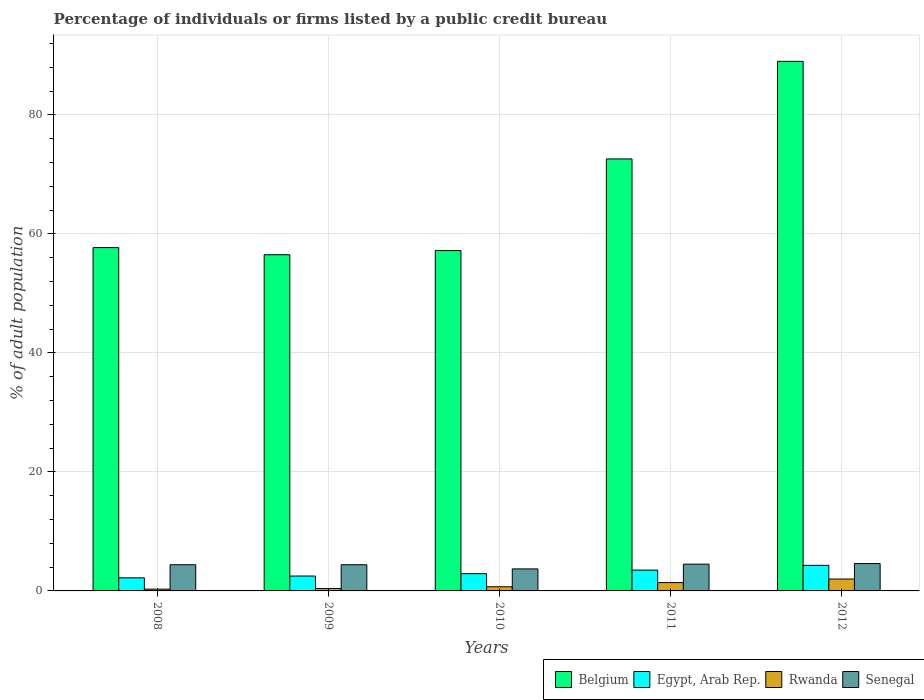How many different coloured bars are there?
Your answer should be very brief. 4. How many bars are there on the 2nd tick from the right?
Your answer should be very brief. 4. What is the label of the 4th group of bars from the left?
Your response must be concise. 2011. What is the percentage of population listed by a public credit bureau in Belgium in 2010?
Your answer should be compact. 57.2. Across all years, what is the maximum percentage of population listed by a public credit bureau in Belgium?
Provide a short and direct response. 89. Across all years, what is the minimum percentage of population listed by a public credit bureau in Rwanda?
Your answer should be compact. 0.3. What is the total percentage of population listed by a public credit bureau in Senegal in the graph?
Your answer should be very brief. 21.6. What is the average percentage of population listed by a public credit bureau in Belgium per year?
Offer a very short reply. 66.6. In the year 2012, what is the difference between the percentage of population listed by a public credit bureau in Senegal and percentage of population listed by a public credit bureau in Rwanda?
Your response must be concise. 2.6. What is the ratio of the percentage of population listed by a public credit bureau in Rwanda in 2011 to that in 2012?
Your answer should be compact. 0.7. Is the difference between the percentage of population listed by a public credit bureau in Senegal in 2008 and 2011 greater than the difference between the percentage of population listed by a public credit bureau in Rwanda in 2008 and 2011?
Ensure brevity in your answer.  Yes. What is the difference between the highest and the second highest percentage of population listed by a public credit bureau in Rwanda?
Keep it short and to the point. 0.6. What is the difference between the highest and the lowest percentage of population listed by a public credit bureau in Rwanda?
Provide a short and direct response. 1.7. Is the sum of the percentage of population listed by a public credit bureau in Rwanda in 2008 and 2009 greater than the maximum percentage of population listed by a public credit bureau in Senegal across all years?
Give a very brief answer. No. Is it the case that in every year, the sum of the percentage of population listed by a public credit bureau in Rwanda and percentage of population listed by a public credit bureau in Senegal is greater than the sum of percentage of population listed by a public credit bureau in Belgium and percentage of population listed by a public credit bureau in Egypt, Arab Rep.?
Offer a terse response. Yes. Is it the case that in every year, the sum of the percentage of population listed by a public credit bureau in Rwanda and percentage of population listed by a public credit bureau in Senegal is greater than the percentage of population listed by a public credit bureau in Egypt, Arab Rep.?
Keep it short and to the point. Yes. How many bars are there?
Ensure brevity in your answer.  20. How many years are there in the graph?
Provide a short and direct response. 5. Are the values on the major ticks of Y-axis written in scientific E-notation?
Your answer should be compact. No. Where does the legend appear in the graph?
Make the answer very short. Bottom right. What is the title of the graph?
Offer a terse response. Percentage of individuals or firms listed by a public credit bureau. Does "Comoros" appear as one of the legend labels in the graph?
Your answer should be very brief. No. What is the label or title of the Y-axis?
Ensure brevity in your answer.  % of adult population. What is the % of adult population in Belgium in 2008?
Ensure brevity in your answer.  57.7. What is the % of adult population in Egypt, Arab Rep. in 2008?
Your answer should be compact. 2.2. What is the % of adult population of Rwanda in 2008?
Make the answer very short. 0.3. What is the % of adult population of Belgium in 2009?
Keep it short and to the point. 56.5. What is the % of adult population in Egypt, Arab Rep. in 2009?
Provide a short and direct response. 2.5. What is the % of adult population in Rwanda in 2009?
Offer a very short reply. 0.4. What is the % of adult population in Senegal in 2009?
Offer a very short reply. 4.4. What is the % of adult population of Belgium in 2010?
Make the answer very short. 57.2. What is the % of adult population in Egypt, Arab Rep. in 2010?
Your answer should be very brief. 2.9. What is the % of adult population of Rwanda in 2010?
Your answer should be very brief. 0.7. What is the % of adult population of Belgium in 2011?
Provide a succinct answer. 72.6. What is the % of adult population of Senegal in 2011?
Give a very brief answer. 4.5. What is the % of adult population in Belgium in 2012?
Make the answer very short. 89. What is the % of adult population in Rwanda in 2012?
Keep it short and to the point. 2. What is the % of adult population of Senegal in 2012?
Keep it short and to the point. 4.6. Across all years, what is the maximum % of adult population of Belgium?
Provide a short and direct response. 89. Across all years, what is the maximum % of adult population of Rwanda?
Provide a short and direct response. 2. Across all years, what is the minimum % of adult population of Belgium?
Provide a succinct answer. 56.5. Across all years, what is the minimum % of adult population of Senegal?
Offer a very short reply. 3.7. What is the total % of adult population of Belgium in the graph?
Keep it short and to the point. 333. What is the total % of adult population in Senegal in the graph?
Your answer should be very brief. 21.6. What is the difference between the % of adult population in Belgium in 2008 and that in 2009?
Keep it short and to the point. 1.2. What is the difference between the % of adult population of Egypt, Arab Rep. in 2008 and that in 2009?
Offer a terse response. -0.3. What is the difference between the % of adult population in Senegal in 2008 and that in 2009?
Your answer should be very brief. 0. What is the difference between the % of adult population of Belgium in 2008 and that in 2010?
Your answer should be very brief. 0.5. What is the difference between the % of adult population of Rwanda in 2008 and that in 2010?
Offer a terse response. -0.4. What is the difference between the % of adult population in Senegal in 2008 and that in 2010?
Your answer should be very brief. 0.7. What is the difference between the % of adult population of Belgium in 2008 and that in 2011?
Give a very brief answer. -14.9. What is the difference between the % of adult population of Rwanda in 2008 and that in 2011?
Give a very brief answer. -1.1. What is the difference between the % of adult population in Senegal in 2008 and that in 2011?
Make the answer very short. -0.1. What is the difference between the % of adult population in Belgium in 2008 and that in 2012?
Make the answer very short. -31.3. What is the difference between the % of adult population in Rwanda in 2008 and that in 2012?
Your answer should be very brief. -1.7. What is the difference between the % of adult population of Senegal in 2008 and that in 2012?
Your answer should be very brief. -0.2. What is the difference between the % of adult population of Egypt, Arab Rep. in 2009 and that in 2010?
Your answer should be compact. -0.4. What is the difference between the % of adult population of Senegal in 2009 and that in 2010?
Offer a terse response. 0.7. What is the difference between the % of adult population of Belgium in 2009 and that in 2011?
Keep it short and to the point. -16.1. What is the difference between the % of adult population in Egypt, Arab Rep. in 2009 and that in 2011?
Offer a terse response. -1. What is the difference between the % of adult population of Rwanda in 2009 and that in 2011?
Provide a succinct answer. -1. What is the difference between the % of adult population in Senegal in 2009 and that in 2011?
Give a very brief answer. -0.1. What is the difference between the % of adult population of Belgium in 2009 and that in 2012?
Make the answer very short. -32.5. What is the difference between the % of adult population in Egypt, Arab Rep. in 2009 and that in 2012?
Make the answer very short. -1.8. What is the difference between the % of adult population of Senegal in 2009 and that in 2012?
Ensure brevity in your answer.  -0.2. What is the difference between the % of adult population in Belgium in 2010 and that in 2011?
Provide a short and direct response. -15.4. What is the difference between the % of adult population of Belgium in 2010 and that in 2012?
Provide a succinct answer. -31.8. What is the difference between the % of adult population of Egypt, Arab Rep. in 2010 and that in 2012?
Ensure brevity in your answer.  -1.4. What is the difference between the % of adult population of Belgium in 2011 and that in 2012?
Provide a succinct answer. -16.4. What is the difference between the % of adult population of Egypt, Arab Rep. in 2011 and that in 2012?
Provide a short and direct response. -0.8. What is the difference between the % of adult population in Rwanda in 2011 and that in 2012?
Offer a terse response. -0.6. What is the difference between the % of adult population in Senegal in 2011 and that in 2012?
Offer a terse response. -0.1. What is the difference between the % of adult population of Belgium in 2008 and the % of adult population of Egypt, Arab Rep. in 2009?
Offer a terse response. 55.2. What is the difference between the % of adult population in Belgium in 2008 and the % of adult population in Rwanda in 2009?
Offer a terse response. 57.3. What is the difference between the % of adult population of Belgium in 2008 and the % of adult population of Senegal in 2009?
Your response must be concise. 53.3. What is the difference between the % of adult population of Egypt, Arab Rep. in 2008 and the % of adult population of Rwanda in 2009?
Offer a terse response. 1.8. What is the difference between the % of adult population in Belgium in 2008 and the % of adult population in Egypt, Arab Rep. in 2010?
Your response must be concise. 54.8. What is the difference between the % of adult population in Egypt, Arab Rep. in 2008 and the % of adult population in Senegal in 2010?
Make the answer very short. -1.5. What is the difference between the % of adult population of Rwanda in 2008 and the % of adult population of Senegal in 2010?
Ensure brevity in your answer.  -3.4. What is the difference between the % of adult population of Belgium in 2008 and the % of adult population of Egypt, Arab Rep. in 2011?
Your answer should be compact. 54.2. What is the difference between the % of adult population in Belgium in 2008 and the % of adult population in Rwanda in 2011?
Offer a terse response. 56.3. What is the difference between the % of adult population in Belgium in 2008 and the % of adult population in Senegal in 2011?
Your answer should be very brief. 53.2. What is the difference between the % of adult population in Egypt, Arab Rep. in 2008 and the % of adult population in Rwanda in 2011?
Give a very brief answer. 0.8. What is the difference between the % of adult population in Rwanda in 2008 and the % of adult population in Senegal in 2011?
Make the answer very short. -4.2. What is the difference between the % of adult population in Belgium in 2008 and the % of adult population in Egypt, Arab Rep. in 2012?
Your answer should be very brief. 53.4. What is the difference between the % of adult population of Belgium in 2008 and the % of adult population of Rwanda in 2012?
Give a very brief answer. 55.7. What is the difference between the % of adult population of Belgium in 2008 and the % of adult population of Senegal in 2012?
Give a very brief answer. 53.1. What is the difference between the % of adult population of Egypt, Arab Rep. in 2008 and the % of adult population of Senegal in 2012?
Offer a very short reply. -2.4. What is the difference between the % of adult population of Rwanda in 2008 and the % of adult population of Senegal in 2012?
Provide a short and direct response. -4.3. What is the difference between the % of adult population of Belgium in 2009 and the % of adult population of Egypt, Arab Rep. in 2010?
Give a very brief answer. 53.6. What is the difference between the % of adult population in Belgium in 2009 and the % of adult population in Rwanda in 2010?
Provide a succinct answer. 55.8. What is the difference between the % of adult population of Belgium in 2009 and the % of adult population of Senegal in 2010?
Ensure brevity in your answer.  52.8. What is the difference between the % of adult population of Egypt, Arab Rep. in 2009 and the % of adult population of Rwanda in 2010?
Provide a succinct answer. 1.8. What is the difference between the % of adult population in Egypt, Arab Rep. in 2009 and the % of adult population in Senegal in 2010?
Make the answer very short. -1.2. What is the difference between the % of adult population of Belgium in 2009 and the % of adult population of Egypt, Arab Rep. in 2011?
Give a very brief answer. 53. What is the difference between the % of adult population of Belgium in 2009 and the % of adult population of Rwanda in 2011?
Your answer should be compact. 55.1. What is the difference between the % of adult population in Belgium in 2009 and the % of adult population in Senegal in 2011?
Offer a very short reply. 52. What is the difference between the % of adult population in Egypt, Arab Rep. in 2009 and the % of adult population in Rwanda in 2011?
Make the answer very short. 1.1. What is the difference between the % of adult population of Rwanda in 2009 and the % of adult population of Senegal in 2011?
Give a very brief answer. -4.1. What is the difference between the % of adult population in Belgium in 2009 and the % of adult population in Egypt, Arab Rep. in 2012?
Provide a succinct answer. 52.2. What is the difference between the % of adult population in Belgium in 2009 and the % of adult population in Rwanda in 2012?
Provide a succinct answer. 54.5. What is the difference between the % of adult population of Belgium in 2009 and the % of adult population of Senegal in 2012?
Offer a very short reply. 51.9. What is the difference between the % of adult population of Egypt, Arab Rep. in 2009 and the % of adult population of Senegal in 2012?
Offer a very short reply. -2.1. What is the difference between the % of adult population in Belgium in 2010 and the % of adult population in Egypt, Arab Rep. in 2011?
Give a very brief answer. 53.7. What is the difference between the % of adult population of Belgium in 2010 and the % of adult population of Rwanda in 2011?
Give a very brief answer. 55.8. What is the difference between the % of adult population of Belgium in 2010 and the % of adult population of Senegal in 2011?
Provide a succinct answer. 52.7. What is the difference between the % of adult population of Egypt, Arab Rep. in 2010 and the % of adult population of Senegal in 2011?
Your response must be concise. -1.6. What is the difference between the % of adult population in Rwanda in 2010 and the % of adult population in Senegal in 2011?
Your response must be concise. -3.8. What is the difference between the % of adult population in Belgium in 2010 and the % of adult population in Egypt, Arab Rep. in 2012?
Keep it short and to the point. 52.9. What is the difference between the % of adult population in Belgium in 2010 and the % of adult population in Rwanda in 2012?
Make the answer very short. 55.2. What is the difference between the % of adult population of Belgium in 2010 and the % of adult population of Senegal in 2012?
Your answer should be compact. 52.6. What is the difference between the % of adult population in Egypt, Arab Rep. in 2010 and the % of adult population in Rwanda in 2012?
Keep it short and to the point. 0.9. What is the difference between the % of adult population of Egypt, Arab Rep. in 2010 and the % of adult population of Senegal in 2012?
Offer a terse response. -1.7. What is the difference between the % of adult population in Rwanda in 2010 and the % of adult population in Senegal in 2012?
Your answer should be very brief. -3.9. What is the difference between the % of adult population of Belgium in 2011 and the % of adult population of Egypt, Arab Rep. in 2012?
Ensure brevity in your answer.  68.3. What is the difference between the % of adult population of Belgium in 2011 and the % of adult population of Rwanda in 2012?
Your response must be concise. 70.6. What is the difference between the % of adult population in Egypt, Arab Rep. in 2011 and the % of adult population in Rwanda in 2012?
Offer a terse response. 1.5. What is the average % of adult population in Belgium per year?
Your answer should be very brief. 66.6. What is the average % of adult population in Egypt, Arab Rep. per year?
Ensure brevity in your answer.  3.08. What is the average % of adult population of Rwanda per year?
Make the answer very short. 0.96. What is the average % of adult population of Senegal per year?
Your answer should be compact. 4.32. In the year 2008, what is the difference between the % of adult population of Belgium and % of adult population of Egypt, Arab Rep.?
Provide a succinct answer. 55.5. In the year 2008, what is the difference between the % of adult population of Belgium and % of adult population of Rwanda?
Your answer should be very brief. 57.4. In the year 2008, what is the difference between the % of adult population in Belgium and % of adult population in Senegal?
Keep it short and to the point. 53.3. In the year 2008, what is the difference between the % of adult population of Egypt, Arab Rep. and % of adult population of Rwanda?
Offer a very short reply. 1.9. In the year 2008, what is the difference between the % of adult population in Egypt, Arab Rep. and % of adult population in Senegal?
Your answer should be compact. -2.2. In the year 2009, what is the difference between the % of adult population in Belgium and % of adult population in Rwanda?
Provide a succinct answer. 56.1. In the year 2009, what is the difference between the % of adult population of Belgium and % of adult population of Senegal?
Offer a very short reply. 52.1. In the year 2009, what is the difference between the % of adult population in Egypt, Arab Rep. and % of adult population in Senegal?
Your answer should be compact. -1.9. In the year 2009, what is the difference between the % of adult population in Rwanda and % of adult population in Senegal?
Your answer should be compact. -4. In the year 2010, what is the difference between the % of adult population of Belgium and % of adult population of Egypt, Arab Rep.?
Give a very brief answer. 54.3. In the year 2010, what is the difference between the % of adult population of Belgium and % of adult population of Rwanda?
Offer a very short reply. 56.5. In the year 2010, what is the difference between the % of adult population in Belgium and % of adult population in Senegal?
Offer a very short reply. 53.5. In the year 2010, what is the difference between the % of adult population in Egypt, Arab Rep. and % of adult population in Senegal?
Ensure brevity in your answer.  -0.8. In the year 2010, what is the difference between the % of adult population of Rwanda and % of adult population of Senegal?
Keep it short and to the point. -3. In the year 2011, what is the difference between the % of adult population in Belgium and % of adult population in Egypt, Arab Rep.?
Offer a very short reply. 69.1. In the year 2011, what is the difference between the % of adult population in Belgium and % of adult population in Rwanda?
Offer a very short reply. 71.2. In the year 2011, what is the difference between the % of adult population in Belgium and % of adult population in Senegal?
Keep it short and to the point. 68.1. In the year 2011, what is the difference between the % of adult population in Egypt, Arab Rep. and % of adult population in Senegal?
Offer a terse response. -1. In the year 2012, what is the difference between the % of adult population in Belgium and % of adult population in Egypt, Arab Rep.?
Provide a short and direct response. 84.7. In the year 2012, what is the difference between the % of adult population in Belgium and % of adult population in Rwanda?
Provide a succinct answer. 87. In the year 2012, what is the difference between the % of adult population in Belgium and % of adult population in Senegal?
Your answer should be compact. 84.4. In the year 2012, what is the difference between the % of adult population in Rwanda and % of adult population in Senegal?
Your answer should be compact. -2.6. What is the ratio of the % of adult population of Belgium in 2008 to that in 2009?
Your response must be concise. 1.02. What is the ratio of the % of adult population in Egypt, Arab Rep. in 2008 to that in 2009?
Give a very brief answer. 0.88. What is the ratio of the % of adult population of Senegal in 2008 to that in 2009?
Give a very brief answer. 1. What is the ratio of the % of adult population of Belgium in 2008 to that in 2010?
Your response must be concise. 1.01. What is the ratio of the % of adult population in Egypt, Arab Rep. in 2008 to that in 2010?
Provide a short and direct response. 0.76. What is the ratio of the % of adult population of Rwanda in 2008 to that in 2010?
Make the answer very short. 0.43. What is the ratio of the % of adult population of Senegal in 2008 to that in 2010?
Your answer should be compact. 1.19. What is the ratio of the % of adult population in Belgium in 2008 to that in 2011?
Give a very brief answer. 0.79. What is the ratio of the % of adult population in Egypt, Arab Rep. in 2008 to that in 2011?
Give a very brief answer. 0.63. What is the ratio of the % of adult population of Rwanda in 2008 to that in 2011?
Give a very brief answer. 0.21. What is the ratio of the % of adult population of Senegal in 2008 to that in 2011?
Your answer should be compact. 0.98. What is the ratio of the % of adult population in Belgium in 2008 to that in 2012?
Your response must be concise. 0.65. What is the ratio of the % of adult population in Egypt, Arab Rep. in 2008 to that in 2012?
Your response must be concise. 0.51. What is the ratio of the % of adult population of Rwanda in 2008 to that in 2012?
Provide a succinct answer. 0.15. What is the ratio of the % of adult population of Senegal in 2008 to that in 2012?
Give a very brief answer. 0.96. What is the ratio of the % of adult population in Egypt, Arab Rep. in 2009 to that in 2010?
Provide a short and direct response. 0.86. What is the ratio of the % of adult population in Senegal in 2009 to that in 2010?
Offer a very short reply. 1.19. What is the ratio of the % of adult population of Belgium in 2009 to that in 2011?
Make the answer very short. 0.78. What is the ratio of the % of adult population in Rwanda in 2009 to that in 2011?
Your answer should be very brief. 0.29. What is the ratio of the % of adult population of Senegal in 2009 to that in 2011?
Your answer should be very brief. 0.98. What is the ratio of the % of adult population of Belgium in 2009 to that in 2012?
Provide a succinct answer. 0.63. What is the ratio of the % of adult population of Egypt, Arab Rep. in 2009 to that in 2012?
Give a very brief answer. 0.58. What is the ratio of the % of adult population of Senegal in 2009 to that in 2012?
Make the answer very short. 0.96. What is the ratio of the % of adult population in Belgium in 2010 to that in 2011?
Make the answer very short. 0.79. What is the ratio of the % of adult population of Egypt, Arab Rep. in 2010 to that in 2011?
Offer a terse response. 0.83. What is the ratio of the % of adult population in Rwanda in 2010 to that in 2011?
Provide a short and direct response. 0.5. What is the ratio of the % of adult population of Senegal in 2010 to that in 2011?
Keep it short and to the point. 0.82. What is the ratio of the % of adult population in Belgium in 2010 to that in 2012?
Make the answer very short. 0.64. What is the ratio of the % of adult population in Egypt, Arab Rep. in 2010 to that in 2012?
Make the answer very short. 0.67. What is the ratio of the % of adult population in Senegal in 2010 to that in 2012?
Keep it short and to the point. 0.8. What is the ratio of the % of adult population in Belgium in 2011 to that in 2012?
Your response must be concise. 0.82. What is the ratio of the % of adult population of Egypt, Arab Rep. in 2011 to that in 2012?
Your response must be concise. 0.81. What is the ratio of the % of adult population in Rwanda in 2011 to that in 2012?
Offer a very short reply. 0.7. What is the ratio of the % of adult population of Senegal in 2011 to that in 2012?
Your answer should be very brief. 0.98. What is the difference between the highest and the second highest % of adult population of Rwanda?
Offer a very short reply. 0.6. What is the difference between the highest and the lowest % of adult population in Belgium?
Your answer should be compact. 32.5. What is the difference between the highest and the lowest % of adult population of Egypt, Arab Rep.?
Offer a very short reply. 2.1. What is the difference between the highest and the lowest % of adult population of Rwanda?
Offer a very short reply. 1.7. 